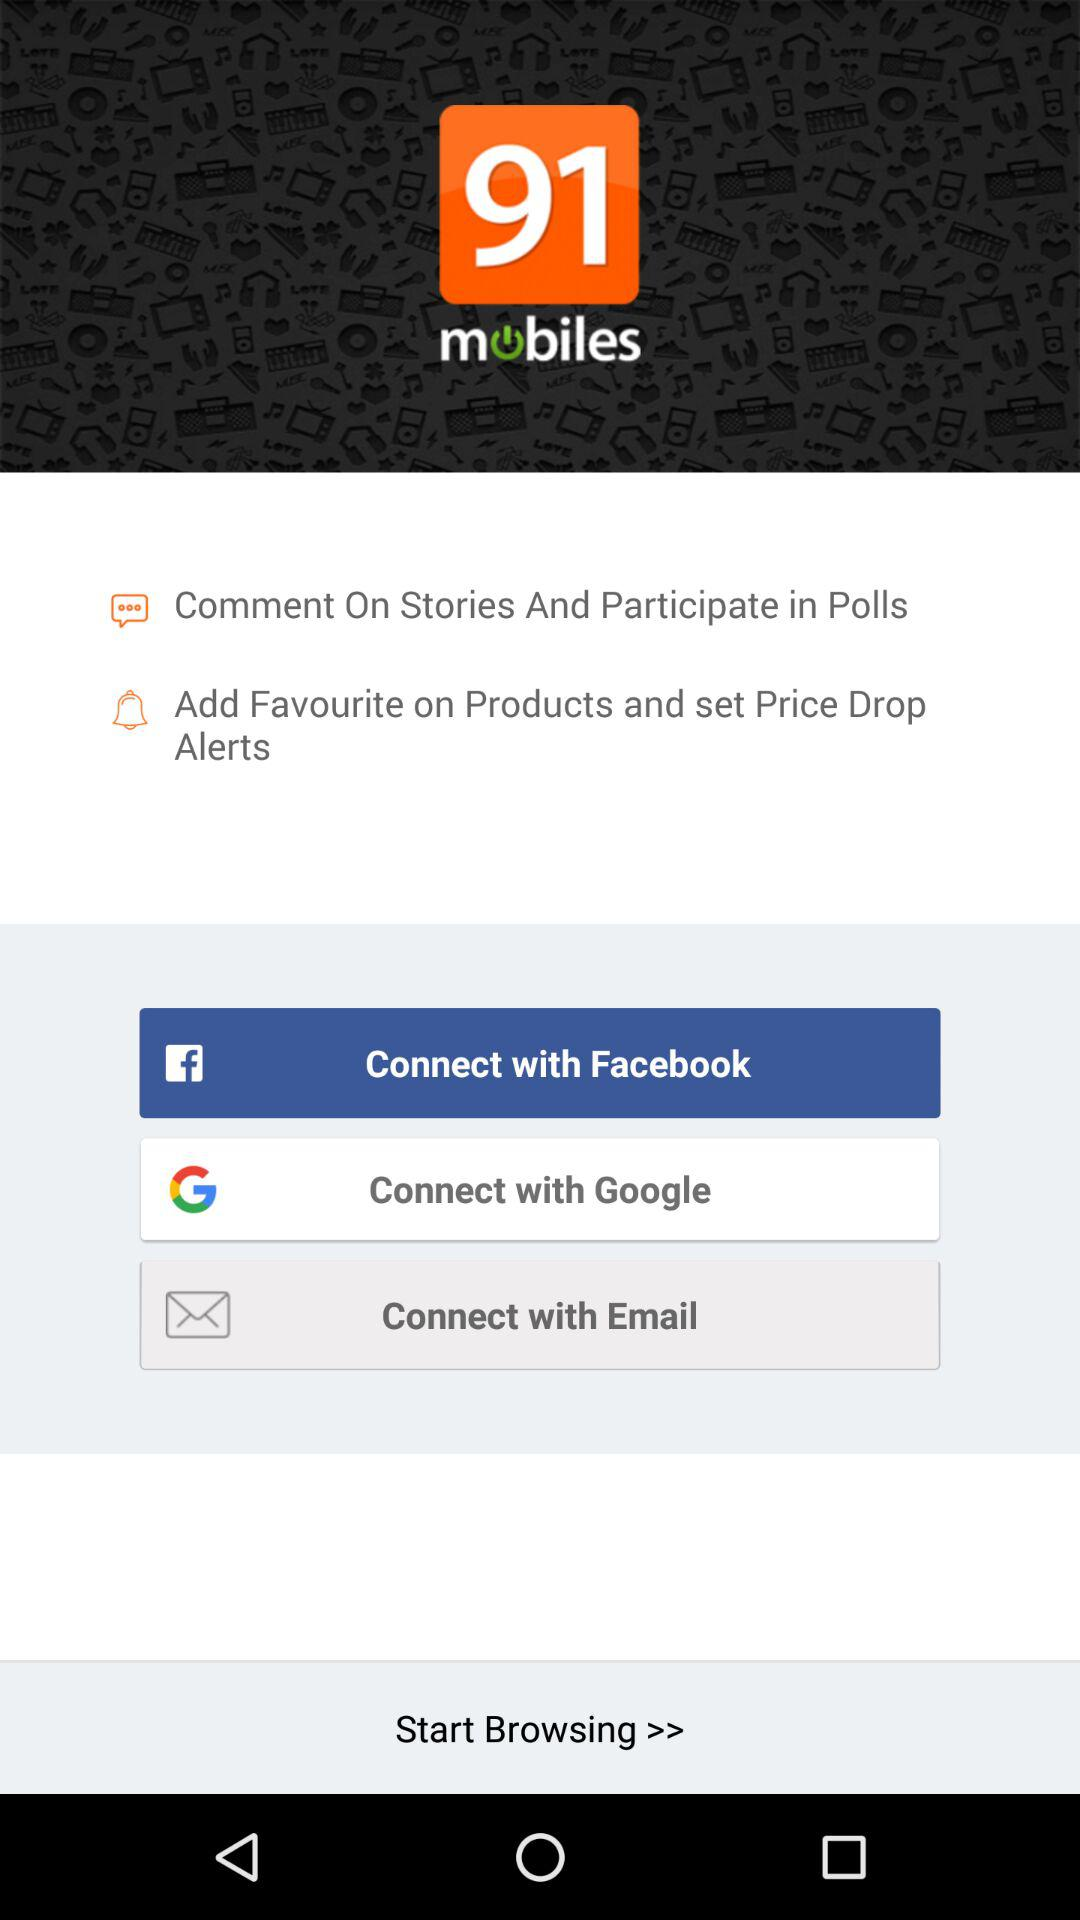Which options are given for connecting? The given options for connecting are "Facebook", "Google" and "Email". 